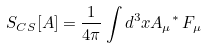<formula> <loc_0><loc_0><loc_500><loc_500>S _ { C S } [ A ] = \frac { 1 } { 4 \pi } \int d ^ { 3 } x A _ { \mu } { ^ { * } \, F _ { \mu } }</formula> 